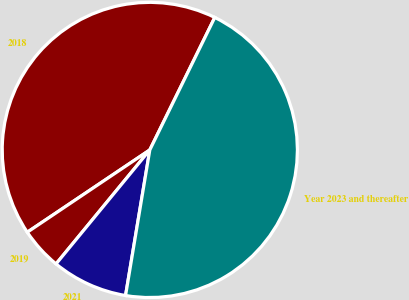Convert chart. <chart><loc_0><loc_0><loc_500><loc_500><pie_chart><fcel>2018<fcel>2019<fcel>2021<fcel>Year 2023 and thereafter<nl><fcel>41.67%<fcel>4.63%<fcel>8.33%<fcel>45.37%<nl></chart> 